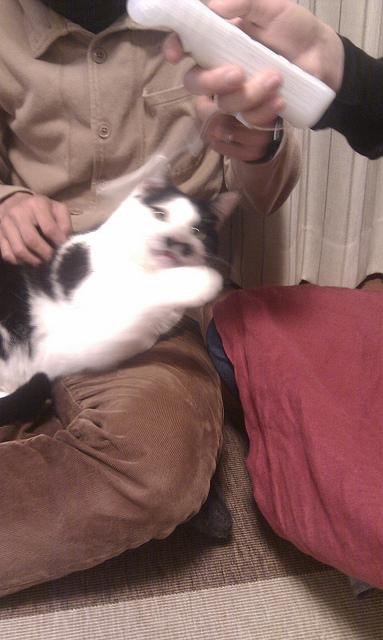What year was this video game console first released? Please explain your reasoning. 2006. The year was 2006. 